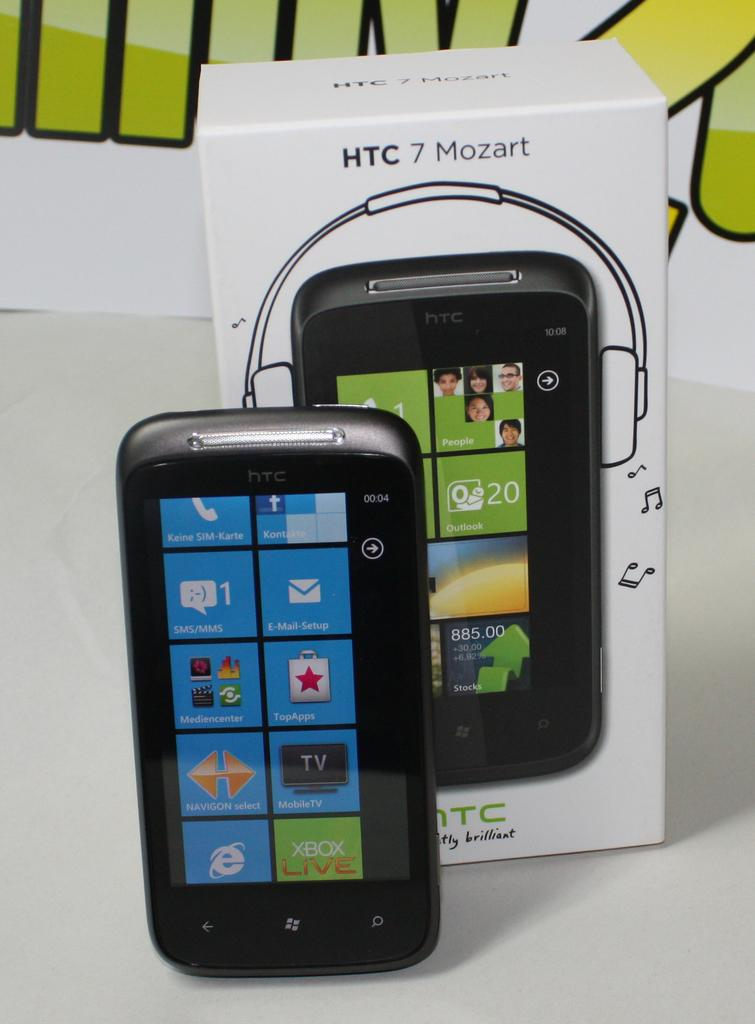<image>
Offer a succinct explanation of the picture presented. an HTC 7 Mozart cell phone with box. 